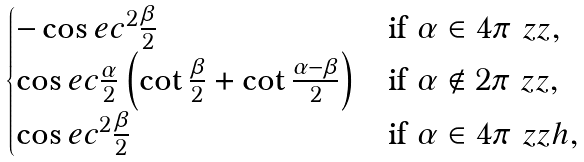Convert formula to latex. <formula><loc_0><loc_0><loc_500><loc_500>\begin{cases} - \cos e c ^ { 2 } \frac { \beta } { 2 } & \text {if } \alpha \in 4 \pi \ z z , \\ { \cos e c \frac { \alpha } { 2 } } \left ( \cot \frac { \beta } { 2 } + \cot \frac { \alpha - \beta } 2 \right ) & \text {if } \alpha \notin 2 \pi \ z z , \\ { \cos e c ^ { 2 } \frac { \beta } { 2 } } & \text {if } \alpha \in 4 \pi \ z z h , \\ \end{cases}</formula> 